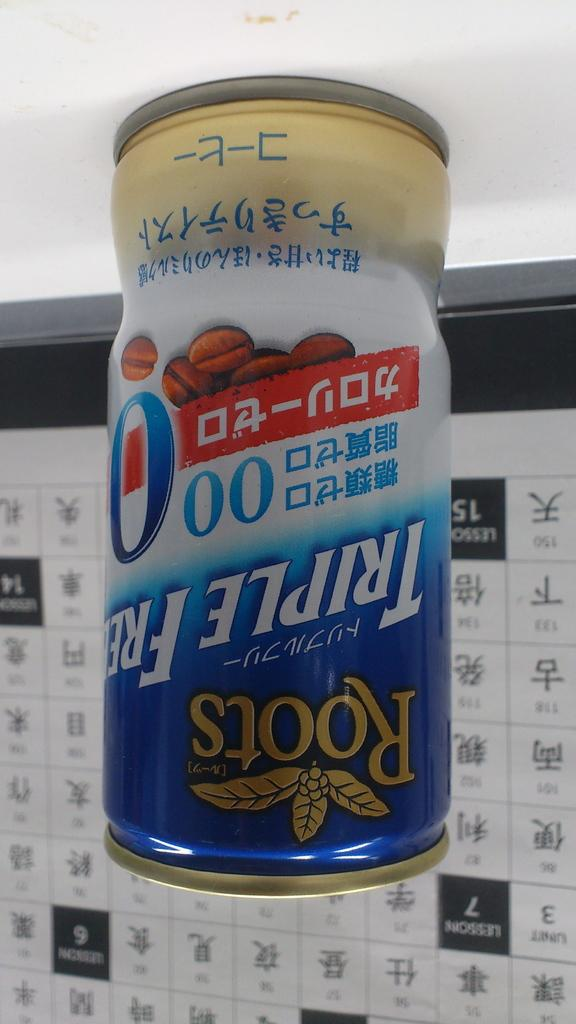Provide a one-sentence caption for the provided image. the word Roots that is on some kind of can. 